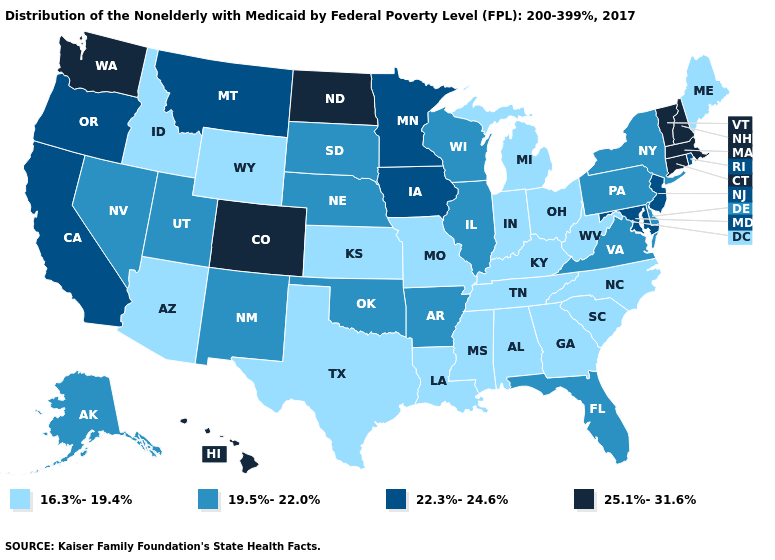Among the states that border New Jersey , which have the lowest value?
Give a very brief answer. Delaware, New York, Pennsylvania. Which states have the lowest value in the USA?
Concise answer only. Alabama, Arizona, Georgia, Idaho, Indiana, Kansas, Kentucky, Louisiana, Maine, Michigan, Mississippi, Missouri, North Carolina, Ohio, South Carolina, Tennessee, Texas, West Virginia, Wyoming. What is the value of North Carolina?
Keep it brief. 16.3%-19.4%. Does the first symbol in the legend represent the smallest category?
Quick response, please. Yes. Which states have the lowest value in the USA?
Answer briefly. Alabama, Arizona, Georgia, Idaho, Indiana, Kansas, Kentucky, Louisiana, Maine, Michigan, Mississippi, Missouri, North Carolina, Ohio, South Carolina, Tennessee, Texas, West Virginia, Wyoming. What is the value of Tennessee?
Be succinct. 16.3%-19.4%. What is the lowest value in states that border Alabama?
Be succinct. 16.3%-19.4%. What is the value of Delaware?
Answer briefly. 19.5%-22.0%. Among the states that border Connecticut , which have the lowest value?
Write a very short answer. New York. Name the states that have a value in the range 19.5%-22.0%?
Short answer required. Alaska, Arkansas, Delaware, Florida, Illinois, Nebraska, Nevada, New Mexico, New York, Oklahoma, Pennsylvania, South Dakota, Utah, Virginia, Wisconsin. Among the states that border North Carolina , which have the highest value?
Be succinct. Virginia. Name the states that have a value in the range 16.3%-19.4%?
Keep it brief. Alabama, Arizona, Georgia, Idaho, Indiana, Kansas, Kentucky, Louisiana, Maine, Michigan, Mississippi, Missouri, North Carolina, Ohio, South Carolina, Tennessee, Texas, West Virginia, Wyoming. Does Vermont have the same value as Maine?
Be succinct. No. Name the states that have a value in the range 25.1%-31.6%?
Short answer required. Colorado, Connecticut, Hawaii, Massachusetts, New Hampshire, North Dakota, Vermont, Washington. Name the states that have a value in the range 16.3%-19.4%?
Keep it brief. Alabama, Arizona, Georgia, Idaho, Indiana, Kansas, Kentucky, Louisiana, Maine, Michigan, Mississippi, Missouri, North Carolina, Ohio, South Carolina, Tennessee, Texas, West Virginia, Wyoming. 